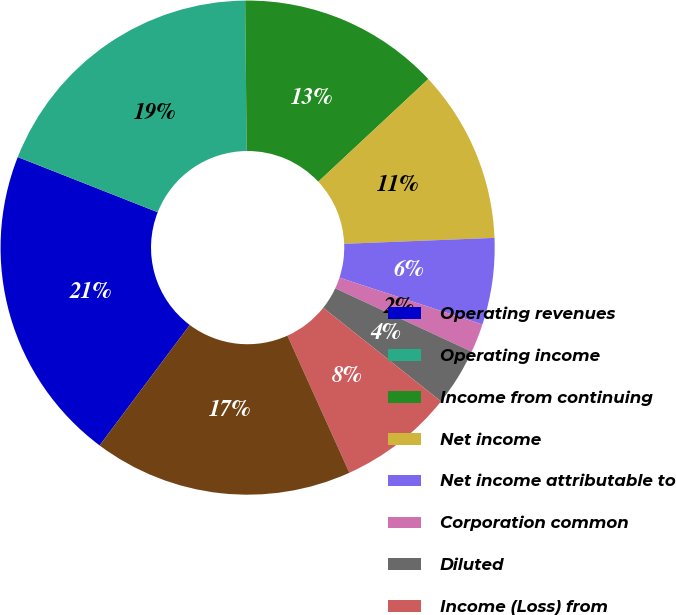Convert chart to OTSL. <chart><loc_0><loc_0><loc_500><loc_500><pie_chart><fcel>Operating revenues<fcel>Operating income<fcel>Income from continuing<fcel>Net income<fcel>Net income attributable to<fcel>Corporation common<fcel>Diluted<fcel>Income (Loss) from<fcel>Net income (loss)<nl><fcel>20.75%<fcel>18.87%<fcel>13.21%<fcel>11.32%<fcel>5.66%<fcel>1.89%<fcel>3.77%<fcel>7.55%<fcel>16.98%<nl></chart> 